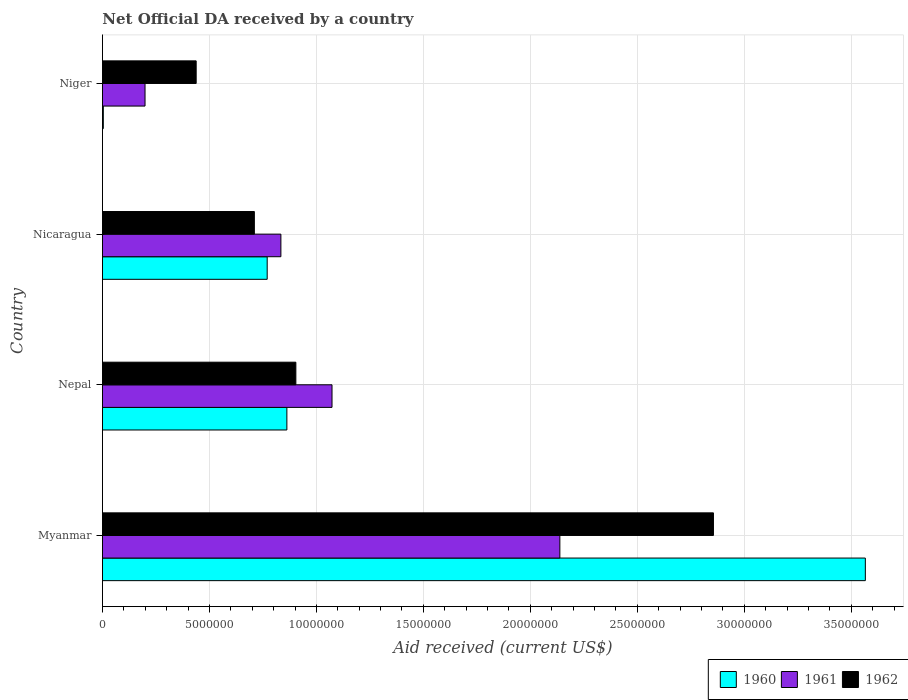How many different coloured bars are there?
Provide a short and direct response. 3. Are the number of bars per tick equal to the number of legend labels?
Your answer should be compact. Yes. Are the number of bars on each tick of the Y-axis equal?
Ensure brevity in your answer.  Yes. How many bars are there on the 3rd tick from the bottom?
Provide a succinct answer. 3. What is the label of the 1st group of bars from the top?
Provide a succinct answer. Niger. In how many cases, is the number of bars for a given country not equal to the number of legend labels?
Keep it short and to the point. 0. What is the net official development assistance aid received in 1960 in Nicaragua?
Your answer should be very brief. 7.70e+06. Across all countries, what is the maximum net official development assistance aid received in 1960?
Provide a succinct answer. 3.57e+07. In which country was the net official development assistance aid received in 1960 maximum?
Keep it short and to the point. Myanmar. In which country was the net official development assistance aid received in 1960 minimum?
Offer a very short reply. Niger. What is the total net official development assistance aid received in 1961 in the graph?
Offer a very short reply. 4.24e+07. What is the difference between the net official development assistance aid received in 1962 in Myanmar and that in Nepal?
Your answer should be very brief. 1.95e+07. What is the difference between the net official development assistance aid received in 1961 in Nepal and the net official development assistance aid received in 1960 in Niger?
Your answer should be very brief. 1.07e+07. What is the average net official development assistance aid received in 1961 per country?
Your answer should be very brief. 1.06e+07. What is the difference between the net official development assistance aid received in 1960 and net official development assistance aid received in 1961 in Myanmar?
Keep it short and to the point. 1.43e+07. What is the ratio of the net official development assistance aid received in 1961 in Nepal to that in Niger?
Ensure brevity in your answer.  5.39. Is the difference between the net official development assistance aid received in 1960 in Myanmar and Nicaragua greater than the difference between the net official development assistance aid received in 1961 in Myanmar and Nicaragua?
Offer a very short reply. Yes. What is the difference between the highest and the second highest net official development assistance aid received in 1962?
Offer a terse response. 1.95e+07. What is the difference between the highest and the lowest net official development assistance aid received in 1961?
Your response must be concise. 1.94e+07. Is it the case that in every country, the sum of the net official development assistance aid received in 1961 and net official development assistance aid received in 1960 is greater than the net official development assistance aid received in 1962?
Your answer should be compact. No. How many bars are there?
Offer a very short reply. 12. Are all the bars in the graph horizontal?
Your answer should be compact. Yes. What is the difference between two consecutive major ticks on the X-axis?
Keep it short and to the point. 5.00e+06. Are the values on the major ticks of X-axis written in scientific E-notation?
Give a very brief answer. No. Does the graph contain any zero values?
Keep it short and to the point. No. How many legend labels are there?
Your answer should be compact. 3. What is the title of the graph?
Offer a terse response. Net Official DA received by a country. Does "1964" appear as one of the legend labels in the graph?
Offer a very short reply. No. What is the label or title of the X-axis?
Ensure brevity in your answer.  Aid received (current US$). What is the label or title of the Y-axis?
Give a very brief answer. Country. What is the Aid received (current US$) of 1960 in Myanmar?
Ensure brevity in your answer.  3.57e+07. What is the Aid received (current US$) of 1961 in Myanmar?
Your response must be concise. 2.14e+07. What is the Aid received (current US$) in 1962 in Myanmar?
Offer a terse response. 2.86e+07. What is the Aid received (current US$) of 1960 in Nepal?
Provide a short and direct response. 8.62e+06. What is the Aid received (current US$) in 1961 in Nepal?
Give a very brief answer. 1.07e+07. What is the Aid received (current US$) of 1962 in Nepal?
Your answer should be very brief. 9.04e+06. What is the Aid received (current US$) in 1960 in Nicaragua?
Provide a succinct answer. 7.70e+06. What is the Aid received (current US$) of 1961 in Nicaragua?
Provide a succinct answer. 8.34e+06. What is the Aid received (current US$) in 1962 in Nicaragua?
Ensure brevity in your answer.  7.10e+06. What is the Aid received (current US$) in 1961 in Niger?
Keep it short and to the point. 1.99e+06. What is the Aid received (current US$) of 1962 in Niger?
Your answer should be very brief. 4.38e+06. Across all countries, what is the maximum Aid received (current US$) of 1960?
Your response must be concise. 3.57e+07. Across all countries, what is the maximum Aid received (current US$) in 1961?
Make the answer very short. 2.14e+07. Across all countries, what is the maximum Aid received (current US$) in 1962?
Offer a very short reply. 2.86e+07. Across all countries, what is the minimum Aid received (current US$) of 1961?
Make the answer very short. 1.99e+06. Across all countries, what is the minimum Aid received (current US$) in 1962?
Make the answer very short. 4.38e+06. What is the total Aid received (current US$) in 1960 in the graph?
Provide a succinct answer. 5.20e+07. What is the total Aid received (current US$) in 1961 in the graph?
Your response must be concise. 4.24e+07. What is the total Aid received (current US$) in 1962 in the graph?
Give a very brief answer. 4.91e+07. What is the difference between the Aid received (current US$) of 1960 in Myanmar and that in Nepal?
Your answer should be very brief. 2.70e+07. What is the difference between the Aid received (current US$) of 1961 in Myanmar and that in Nepal?
Provide a short and direct response. 1.06e+07. What is the difference between the Aid received (current US$) of 1962 in Myanmar and that in Nepal?
Your response must be concise. 1.95e+07. What is the difference between the Aid received (current US$) in 1960 in Myanmar and that in Nicaragua?
Keep it short and to the point. 2.80e+07. What is the difference between the Aid received (current US$) in 1961 in Myanmar and that in Nicaragua?
Offer a very short reply. 1.30e+07. What is the difference between the Aid received (current US$) in 1962 in Myanmar and that in Nicaragua?
Your answer should be very brief. 2.15e+07. What is the difference between the Aid received (current US$) in 1960 in Myanmar and that in Niger?
Ensure brevity in your answer.  3.56e+07. What is the difference between the Aid received (current US$) in 1961 in Myanmar and that in Niger?
Offer a terse response. 1.94e+07. What is the difference between the Aid received (current US$) in 1962 in Myanmar and that in Niger?
Make the answer very short. 2.42e+07. What is the difference between the Aid received (current US$) in 1960 in Nepal and that in Nicaragua?
Your answer should be compact. 9.20e+05. What is the difference between the Aid received (current US$) in 1961 in Nepal and that in Nicaragua?
Your answer should be compact. 2.39e+06. What is the difference between the Aid received (current US$) of 1962 in Nepal and that in Nicaragua?
Keep it short and to the point. 1.94e+06. What is the difference between the Aid received (current US$) in 1960 in Nepal and that in Niger?
Offer a very short reply. 8.58e+06. What is the difference between the Aid received (current US$) of 1961 in Nepal and that in Niger?
Offer a very short reply. 8.74e+06. What is the difference between the Aid received (current US$) in 1962 in Nepal and that in Niger?
Provide a short and direct response. 4.66e+06. What is the difference between the Aid received (current US$) in 1960 in Nicaragua and that in Niger?
Offer a terse response. 7.66e+06. What is the difference between the Aid received (current US$) in 1961 in Nicaragua and that in Niger?
Your answer should be very brief. 6.35e+06. What is the difference between the Aid received (current US$) of 1962 in Nicaragua and that in Niger?
Your answer should be very brief. 2.72e+06. What is the difference between the Aid received (current US$) of 1960 in Myanmar and the Aid received (current US$) of 1961 in Nepal?
Offer a terse response. 2.49e+07. What is the difference between the Aid received (current US$) in 1960 in Myanmar and the Aid received (current US$) in 1962 in Nepal?
Provide a short and direct response. 2.66e+07. What is the difference between the Aid received (current US$) in 1961 in Myanmar and the Aid received (current US$) in 1962 in Nepal?
Offer a terse response. 1.23e+07. What is the difference between the Aid received (current US$) in 1960 in Myanmar and the Aid received (current US$) in 1961 in Nicaragua?
Keep it short and to the point. 2.73e+07. What is the difference between the Aid received (current US$) in 1960 in Myanmar and the Aid received (current US$) in 1962 in Nicaragua?
Your response must be concise. 2.86e+07. What is the difference between the Aid received (current US$) in 1961 in Myanmar and the Aid received (current US$) in 1962 in Nicaragua?
Your answer should be very brief. 1.43e+07. What is the difference between the Aid received (current US$) of 1960 in Myanmar and the Aid received (current US$) of 1961 in Niger?
Give a very brief answer. 3.37e+07. What is the difference between the Aid received (current US$) of 1960 in Myanmar and the Aid received (current US$) of 1962 in Niger?
Ensure brevity in your answer.  3.13e+07. What is the difference between the Aid received (current US$) in 1961 in Myanmar and the Aid received (current US$) in 1962 in Niger?
Your answer should be compact. 1.70e+07. What is the difference between the Aid received (current US$) in 1960 in Nepal and the Aid received (current US$) in 1961 in Nicaragua?
Your response must be concise. 2.80e+05. What is the difference between the Aid received (current US$) of 1960 in Nepal and the Aid received (current US$) of 1962 in Nicaragua?
Keep it short and to the point. 1.52e+06. What is the difference between the Aid received (current US$) of 1961 in Nepal and the Aid received (current US$) of 1962 in Nicaragua?
Your answer should be compact. 3.63e+06. What is the difference between the Aid received (current US$) of 1960 in Nepal and the Aid received (current US$) of 1961 in Niger?
Your answer should be very brief. 6.63e+06. What is the difference between the Aid received (current US$) in 1960 in Nepal and the Aid received (current US$) in 1962 in Niger?
Provide a succinct answer. 4.24e+06. What is the difference between the Aid received (current US$) of 1961 in Nepal and the Aid received (current US$) of 1962 in Niger?
Give a very brief answer. 6.35e+06. What is the difference between the Aid received (current US$) of 1960 in Nicaragua and the Aid received (current US$) of 1961 in Niger?
Offer a very short reply. 5.71e+06. What is the difference between the Aid received (current US$) in 1960 in Nicaragua and the Aid received (current US$) in 1962 in Niger?
Provide a short and direct response. 3.32e+06. What is the difference between the Aid received (current US$) of 1961 in Nicaragua and the Aid received (current US$) of 1962 in Niger?
Offer a very short reply. 3.96e+06. What is the average Aid received (current US$) in 1960 per country?
Provide a short and direct response. 1.30e+07. What is the average Aid received (current US$) in 1961 per country?
Offer a terse response. 1.06e+07. What is the average Aid received (current US$) of 1962 per country?
Keep it short and to the point. 1.23e+07. What is the difference between the Aid received (current US$) of 1960 and Aid received (current US$) of 1961 in Myanmar?
Offer a terse response. 1.43e+07. What is the difference between the Aid received (current US$) of 1960 and Aid received (current US$) of 1962 in Myanmar?
Offer a terse response. 7.10e+06. What is the difference between the Aid received (current US$) in 1961 and Aid received (current US$) in 1962 in Myanmar?
Offer a terse response. -7.18e+06. What is the difference between the Aid received (current US$) in 1960 and Aid received (current US$) in 1961 in Nepal?
Offer a very short reply. -2.11e+06. What is the difference between the Aid received (current US$) of 1960 and Aid received (current US$) of 1962 in Nepal?
Offer a very short reply. -4.20e+05. What is the difference between the Aid received (current US$) of 1961 and Aid received (current US$) of 1962 in Nepal?
Make the answer very short. 1.69e+06. What is the difference between the Aid received (current US$) in 1960 and Aid received (current US$) in 1961 in Nicaragua?
Offer a terse response. -6.40e+05. What is the difference between the Aid received (current US$) of 1961 and Aid received (current US$) of 1962 in Nicaragua?
Your response must be concise. 1.24e+06. What is the difference between the Aid received (current US$) of 1960 and Aid received (current US$) of 1961 in Niger?
Keep it short and to the point. -1.95e+06. What is the difference between the Aid received (current US$) of 1960 and Aid received (current US$) of 1962 in Niger?
Keep it short and to the point. -4.34e+06. What is the difference between the Aid received (current US$) in 1961 and Aid received (current US$) in 1962 in Niger?
Provide a succinct answer. -2.39e+06. What is the ratio of the Aid received (current US$) in 1960 in Myanmar to that in Nepal?
Offer a terse response. 4.14. What is the ratio of the Aid received (current US$) of 1961 in Myanmar to that in Nepal?
Your answer should be compact. 1.99. What is the ratio of the Aid received (current US$) of 1962 in Myanmar to that in Nepal?
Your response must be concise. 3.16. What is the ratio of the Aid received (current US$) in 1960 in Myanmar to that in Nicaragua?
Provide a succinct answer. 4.63. What is the ratio of the Aid received (current US$) in 1961 in Myanmar to that in Nicaragua?
Make the answer very short. 2.56. What is the ratio of the Aid received (current US$) of 1962 in Myanmar to that in Nicaragua?
Ensure brevity in your answer.  4.02. What is the ratio of the Aid received (current US$) in 1960 in Myanmar to that in Niger?
Provide a succinct answer. 891.5. What is the ratio of the Aid received (current US$) of 1961 in Myanmar to that in Niger?
Your response must be concise. 10.74. What is the ratio of the Aid received (current US$) in 1962 in Myanmar to that in Niger?
Offer a terse response. 6.52. What is the ratio of the Aid received (current US$) in 1960 in Nepal to that in Nicaragua?
Your answer should be compact. 1.12. What is the ratio of the Aid received (current US$) in 1961 in Nepal to that in Nicaragua?
Offer a very short reply. 1.29. What is the ratio of the Aid received (current US$) of 1962 in Nepal to that in Nicaragua?
Provide a succinct answer. 1.27. What is the ratio of the Aid received (current US$) in 1960 in Nepal to that in Niger?
Give a very brief answer. 215.5. What is the ratio of the Aid received (current US$) of 1961 in Nepal to that in Niger?
Offer a very short reply. 5.39. What is the ratio of the Aid received (current US$) of 1962 in Nepal to that in Niger?
Provide a succinct answer. 2.06. What is the ratio of the Aid received (current US$) of 1960 in Nicaragua to that in Niger?
Give a very brief answer. 192.5. What is the ratio of the Aid received (current US$) of 1961 in Nicaragua to that in Niger?
Provide a succinct answer. 4.19. What is the ratio of the Aid received (current US$) in 1962 in Nicaragua to that in Niger?
Provide a succinct answer. 1.62. What is the difference between the highest and the second highest Aid received (current US$) in 1960?
Give a very brief answer. 2.70e+07. What is the difference between the highest and the second highest Aid received (current US$) in 1961?
Provide a succinct answer. 1.06e+07. What is the difference between the highest and the second highest Aid received (current US$) of 1962?
Your answer should be compact. 1.95e+07. What is the difference between the highest and the lowest Aid received (current US$) of 1960?
Make the answer very short. 3.56e+07. What is the difference between the highest and the lowest Aid received (current US$) of 1961?
Make the answer very short. 1.94e+07. What is the difference between the highest and the lowest Aid received (current US$) of 1962?
Ensure brevity in your answer.  2.42e+07. 